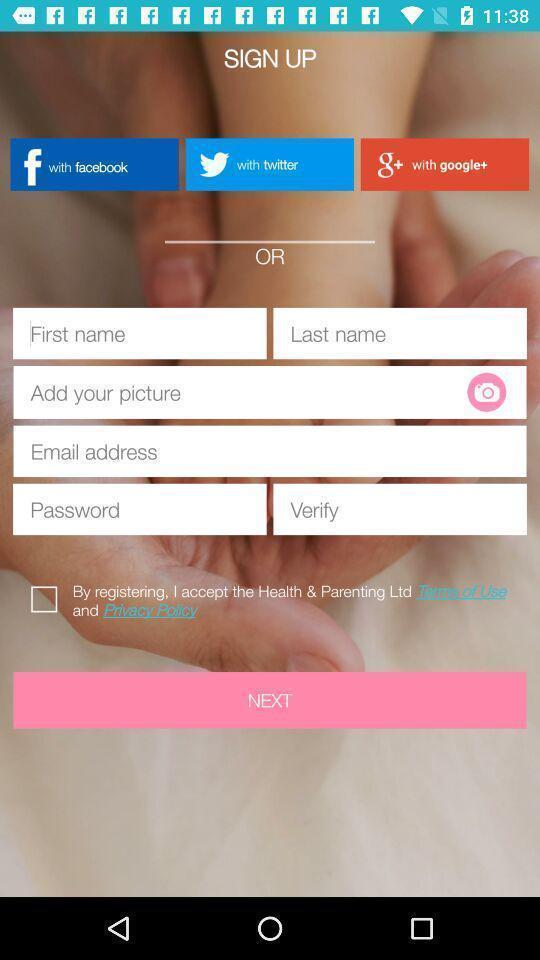Explain what's happening in this screen capture. Signup page of a pregnancy app. 